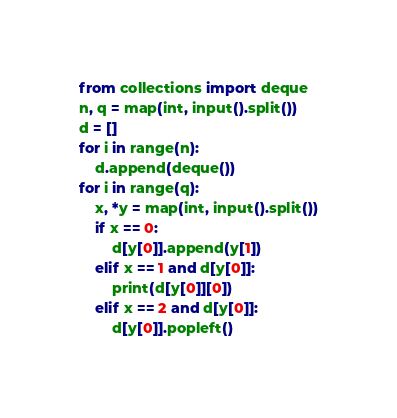<code> <loc_0><loc_0><loc_500><loc_500><_Python_>from collections import deque
n, q = map(int, input().split())
d = []
for i in range(n):
    d.append(deque())
for i in range(q):
    x, *y = map(int, input().split())
    if x == 0:
        d[y[0]].append(y[1])
    elif x == 1 and d[y[0]]:
        print(d[y[0]][0])
    elif x == 2 and d[y[0]]:
        d[y[0]].popleft()

</code> 